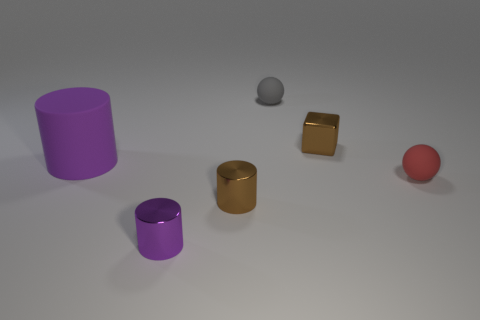How many other objects have the same color as the big object?
Provide a short and direct response. 1. What number of other objects are there of the same shape as the purple metal thing?
Provide a short and direct response. 2. Do the small rubber thing behind the brown metal cube and the small brown metal thing on the right side of the gray sphere have the same shape?
Give a very brief answer. No. There is a small red thing that is in front of the purple object behind the small purple metallic cylinder; what number of small purple shiny cylinders are behind it?
Provide a succinct answer. 0. The large rubber thing is what color?
Your answer should be compact. Purple. How many other things are the same size as the red sphere?
Keep it short and to the point. 4. What is the material of the other large purple object that is the same shape as the purple metal thing?
Your response must be concise. Rubber. There is a tiny brown object behind the tiny matte sphere in front of the small matte sphere that is behind the small brown metal cube; what is its material?
Make the answer very short. Metal. The purple object that is the same material as the red sphere is what size?
Offer a very short reply. Large. Is there any other thing that is the same color as the big cylinder?
Offer a very short reply. Yes. 